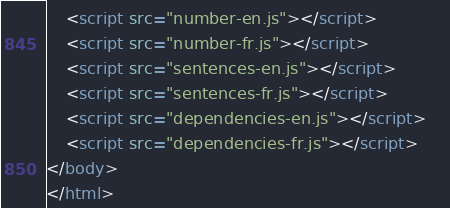Convert code to text. <code><loc_0><loc_0><loc_500><loc_500><_HTML_>    <script src="number-en.js"></script>
    <script src="number-fr.js"></script>
    <script src="sentences-en.js"></script>
    <script src="sentences-fr.js"></script>
	<script src="dependencies-en.js"></script>	
	<script src="dependencies-fr.js"></script>	
</body>
</html></code> 